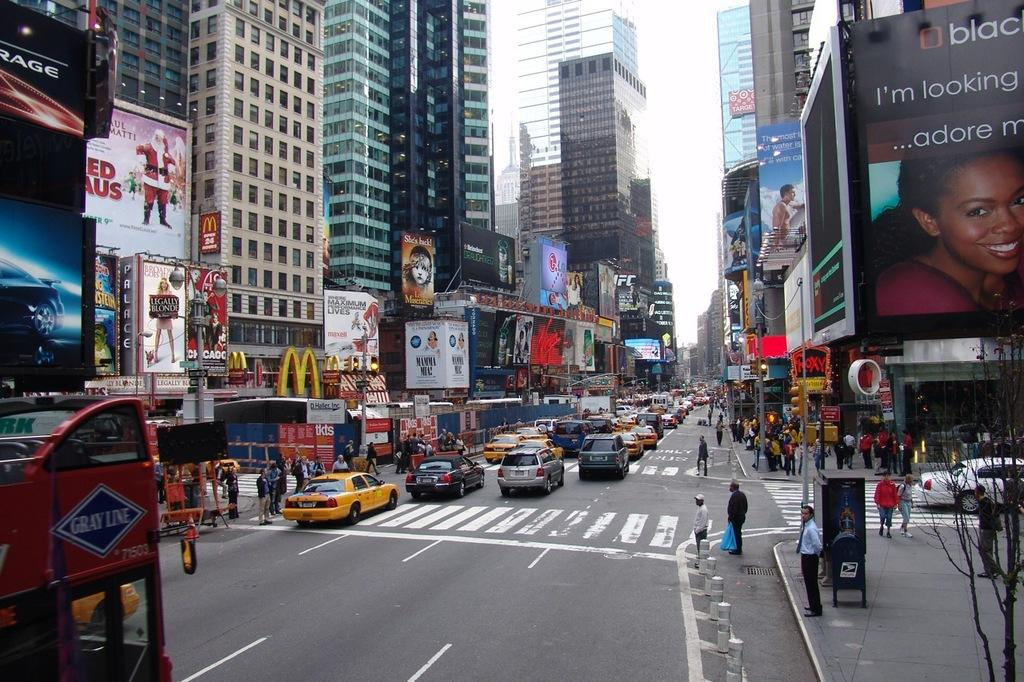<image>
Summarize the visual content of the image. A city street scene with an ad for Les Miserables halfway down. 